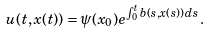Convert formula to latex. <formula><loc_0><loc_0><loc_500><loc_500>u ( t , x ( t ) ) = \psi ( x _ { 0 } ) e ^ { \int _ { 0 } ^ { t } b ( s , x ( s ) ) \, d s } .</formula> 